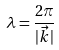Convert formula to latex. <formula><loc_0><loc_0><loc_500><loc_500>\lambda = \frac { 2 \pi } { | \vec { k } | }</formula> 